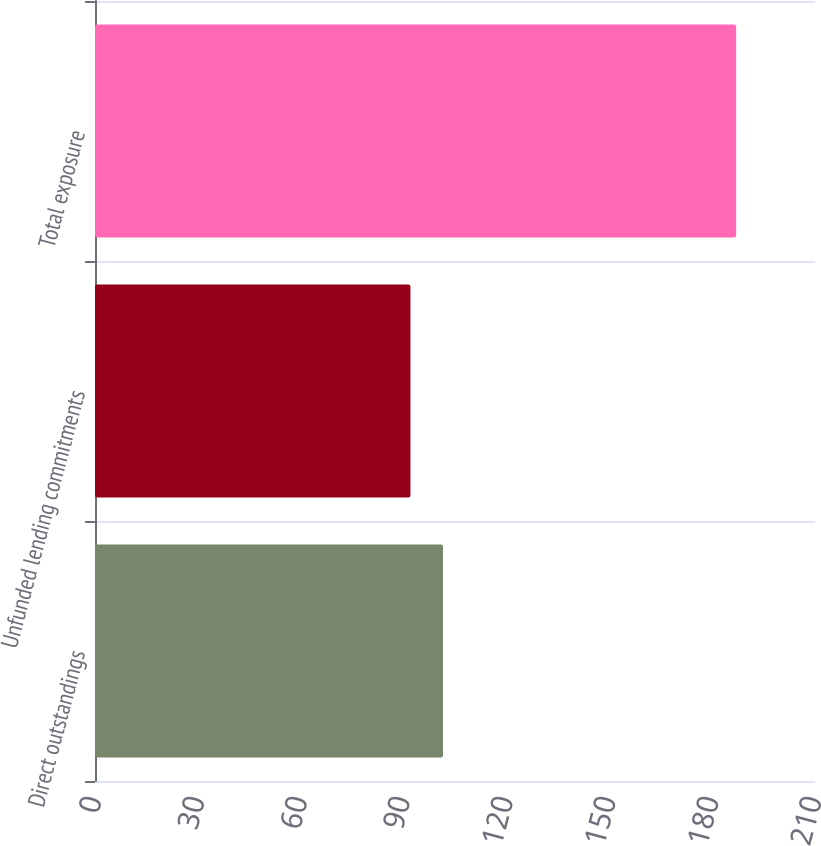Convert chart to OTSL. <chart><loc_0><loc_0><loc_500><loc_500><bar_chart><fcel>Direct outstandings<fcel>Unfunded lending commitments<fcel>Total exposure<nl><fcel>101.5<fcel>92<fcel>187<nl></chart> 